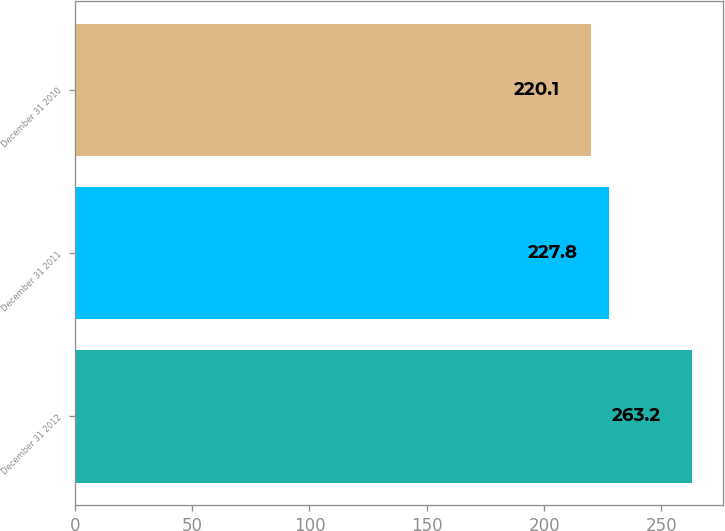Convert chart. <chart><loc_0><loc_0><loc_500><loc_500><bar_chart><fcel>December 31 2012<fcel>December 31 2011<fcel>December 31 2010<nl><fcel>263.2<fcel>227.8<fcel>220.1<nl></chart> 